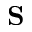Convert formula to latex. <formula><loc_0><loc_0><loc_500><loc_500>{ S }</formula> 